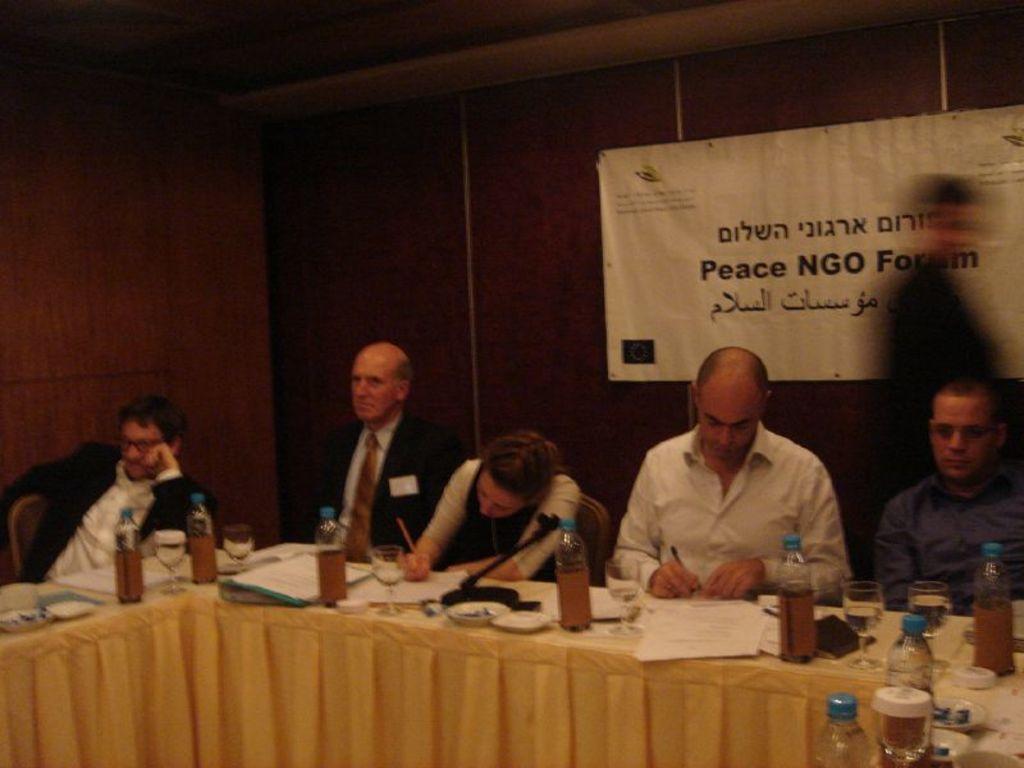Could you give a brief overview of what you see in this image? In this image there are persons sitting on the chair, there is a table, there are objects on the table, there is a person walking, there is a banner truncated towards the right of the image, there is text on the banner, there is a wall truncated towards the left of the image, there is a wall truncated towards the right of the image. 